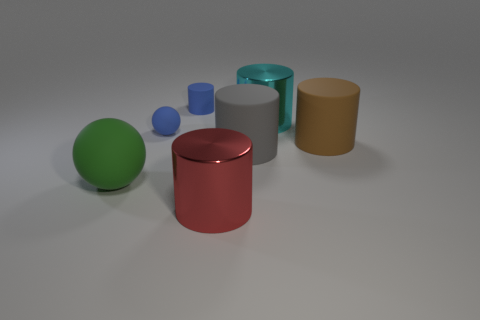Subtract all gray rubber cylinders. How many cylinders are left? 4 Subtract all red cylinders. How many cylinders are left? 4 Add 1 tiny gray blocks. How many objects exist? 8 Subtract all yellow cylinders. Subtract all purple cubes. How many cylinders are left? 5 Subtract all balls. How many objects are left? 5 Add 2 shiny things. How many shiny things exist? 4 Subtract 0 purple cubes. How many objects are left? 7 Subtract all tiny brown matte objects. Subtract all brown objects. How many objects are left? 6 Add 3 large gray rubber cylinders. How many large gray rubber cylinders are left? 4 